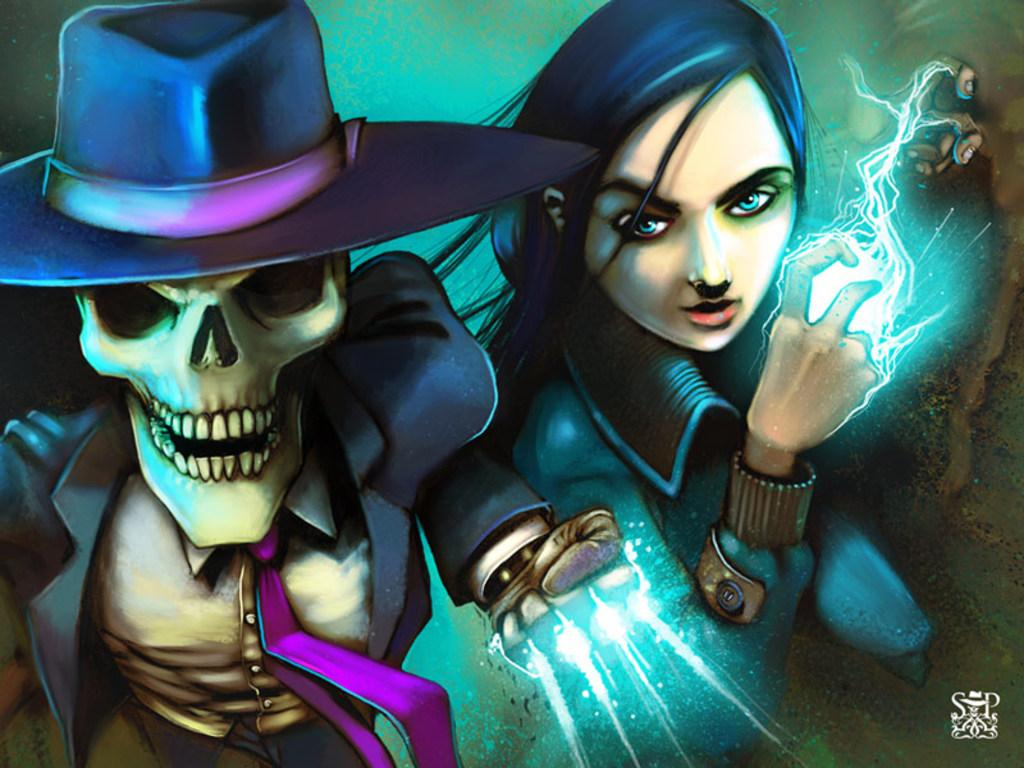What type of picture is in the image? The image contains an animated picture. What character can be seen in the animated picture? There is a skeleton in the image. What is the skeleton wearing on its head? The skeleton is wearing a blue hat. What color is the background of the image? The background of the image is green. How does the skeleton show respect to others in the image? The image does not depict any behavior or actions of the skeleton, so it cannot be determined how it shows respect to others. 